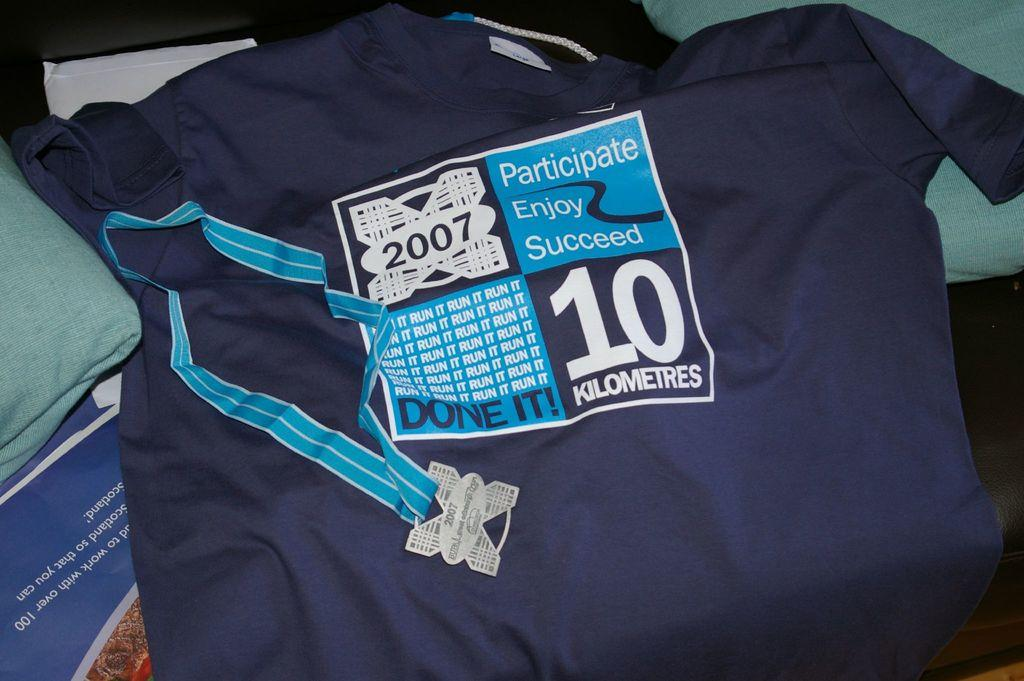Provide a one-sentence caption for the provided image. A shirt is given to those who participate, enjoy and succeed in the 10 kilometer race. 